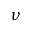<formula> <loc_0><loc_0><loc_500><loc_500>\nu</formula> 